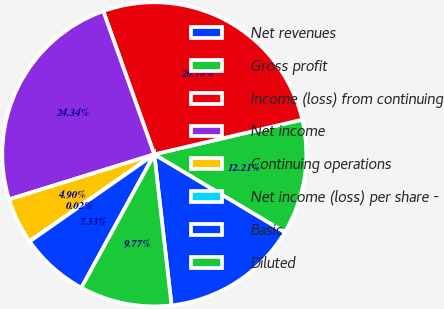<chart> <loc_0><loc_0><loc_500><loc_500><pie_chart><fcel>Net revenues<fcel>Gross profit<fcel>Income (loss) from continuing<fcel>Net income<fcel>Continuing operations<fcel>Net income (loss) per share -<fcel>Basic<fcel>Diluted<nl><fcel>14.64%<fcel>12.21%<fcel>26.78%<fcel>24.34%<fcel>4.9%<fcel>0.02%<fcel>7.33%<fcel>9.77%<nl></chart> 